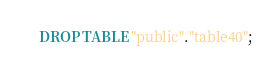Convert code to text. <code><loc_0><loc_0><loc_500><loc_500><_SQL_>DROP TABLE "public"."table40";
</code> 